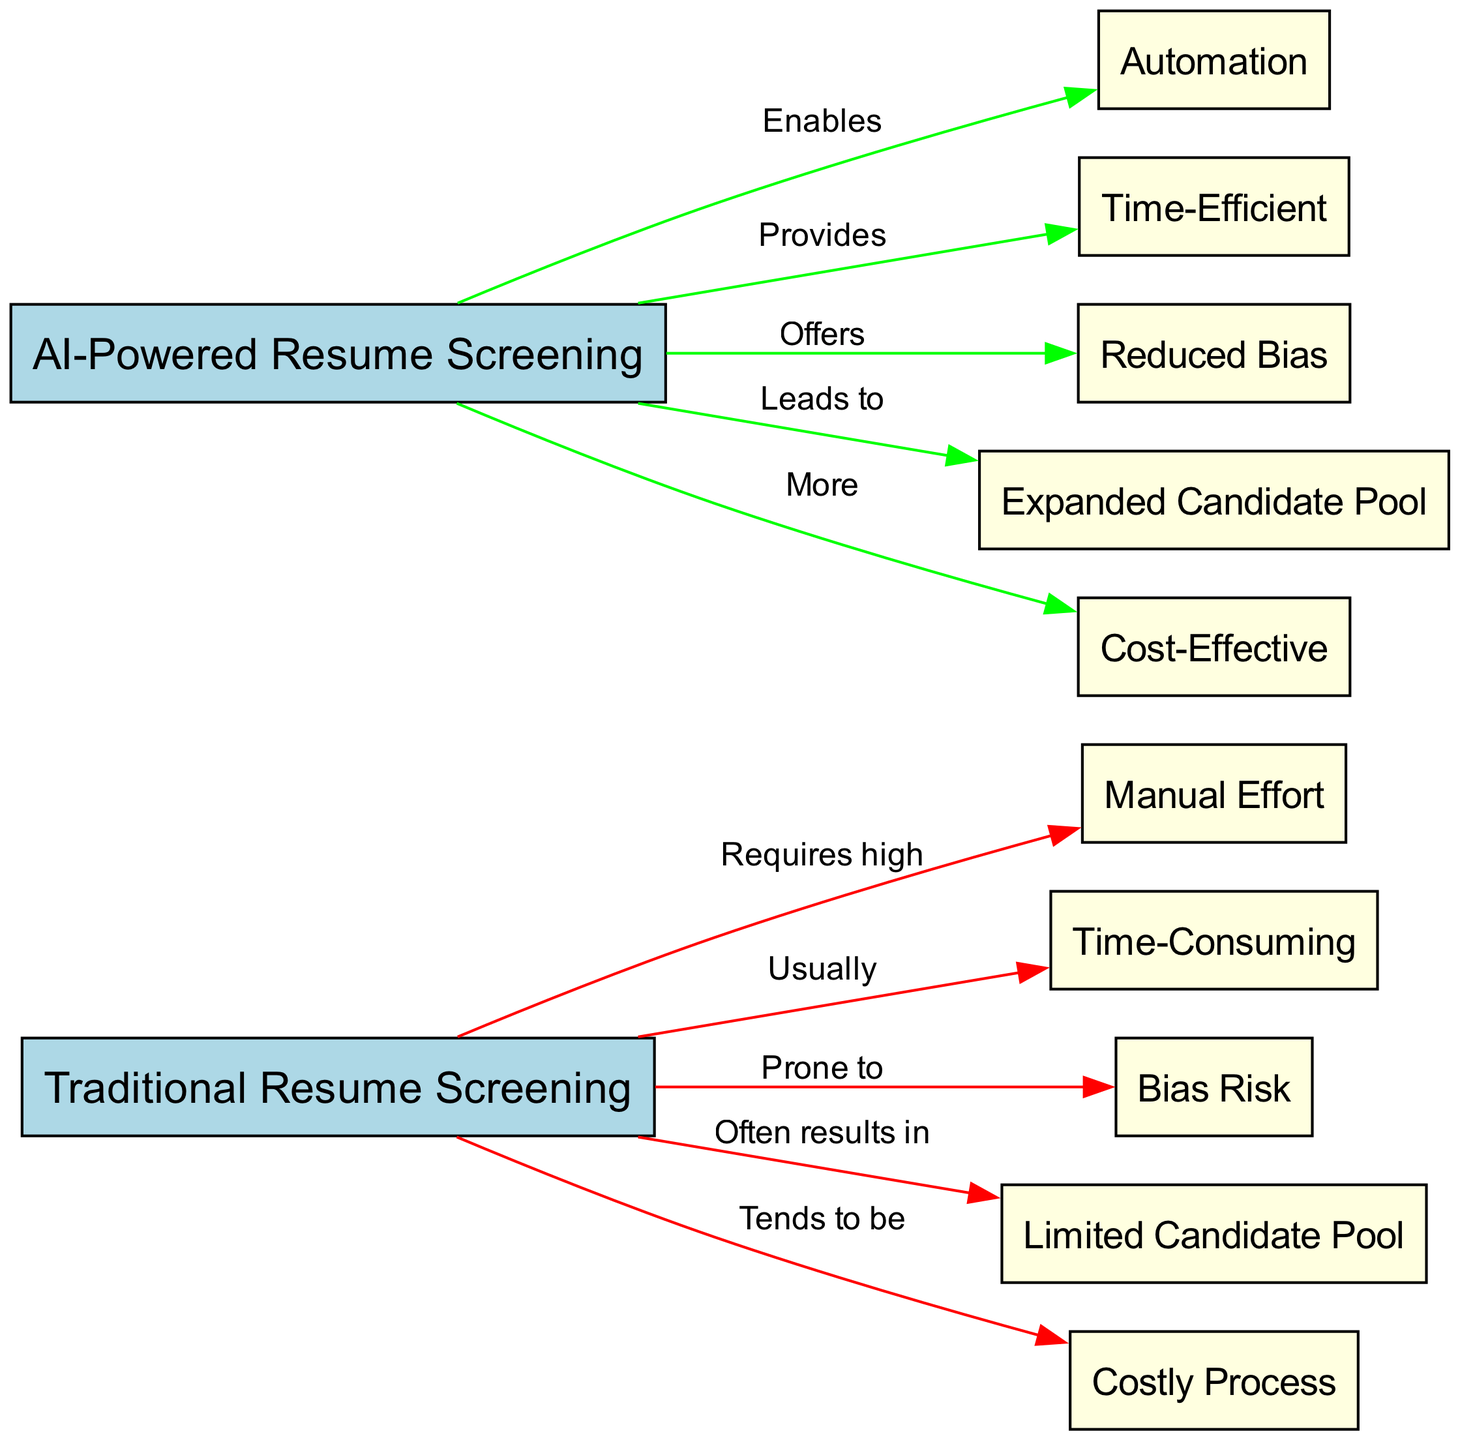What is the main focus of the diagram? The diagram compares two methods of resume screening: Traditional Resume Screening and AI-Powered Resume Screening. This is evident from the two main nodes that serve as the primary subjects of the analysis.
Answer: Comparative Analysis of Traditional vs. AI-Powered Resume Screening How many total nodes are present in the diagram? By counting all the distinct nodes mentioned, there are twelve nodes in total.
Answer: 12 What is one feature of Traditional Resume Screening? The diagram shows that Traditional Resume Screening is "Time-Consuming", which is directly stated as one of its properties connected to the main node for Traditional Resume Screening.
Answer: Time-Consuming What effect does AI-Powered Resume Screening have on the candidate pool? The diagram illustrates that AI-Powered Resume Screening "Leads to Expanded Candidate Pool", indicating a broader range of candidates due to its automated and unbiased nature.
Answer: Expanded Candidate Pool What type of effort does Traditional Resume Screening require? The diagram indicates that Traditional Resume Screening "Requires high Manual Effort", showing the demanding nature of this process in terms of human resources.
Answer: high Manual Effort What is one risk associated with Traditional Resume Screening? The diagram notes that Traditional Resume Screening is "Prone to Bias Risk", highlighting a significant drawback of relying solely on manual processes.
Answer: Bias Risk What advantage does AI-Powered Resume Screening offer regarding bias? The diagram states that AI-Powered Resume Screening "Offers Reduced Bias", showcasing its advantage in minimizing subjective decision-making flaws.
Answer: Reduced Bias How does AI-Powered Resume Screening impact costs? According to the diagram, AI-Powered Resume Screening is described as "More Cost-Effective", suggesting savings compared to Traditional methods.
Answer: More Cost-Effective What is a consequence of Traditional Resume Screening regarding the hiring process? The diagram depicts that Traditional Resume Screening "Often results in Limited Candidate Pool", illustrating its restrictive nature in candidate selection.
Answer: Limited Candidate Pool 